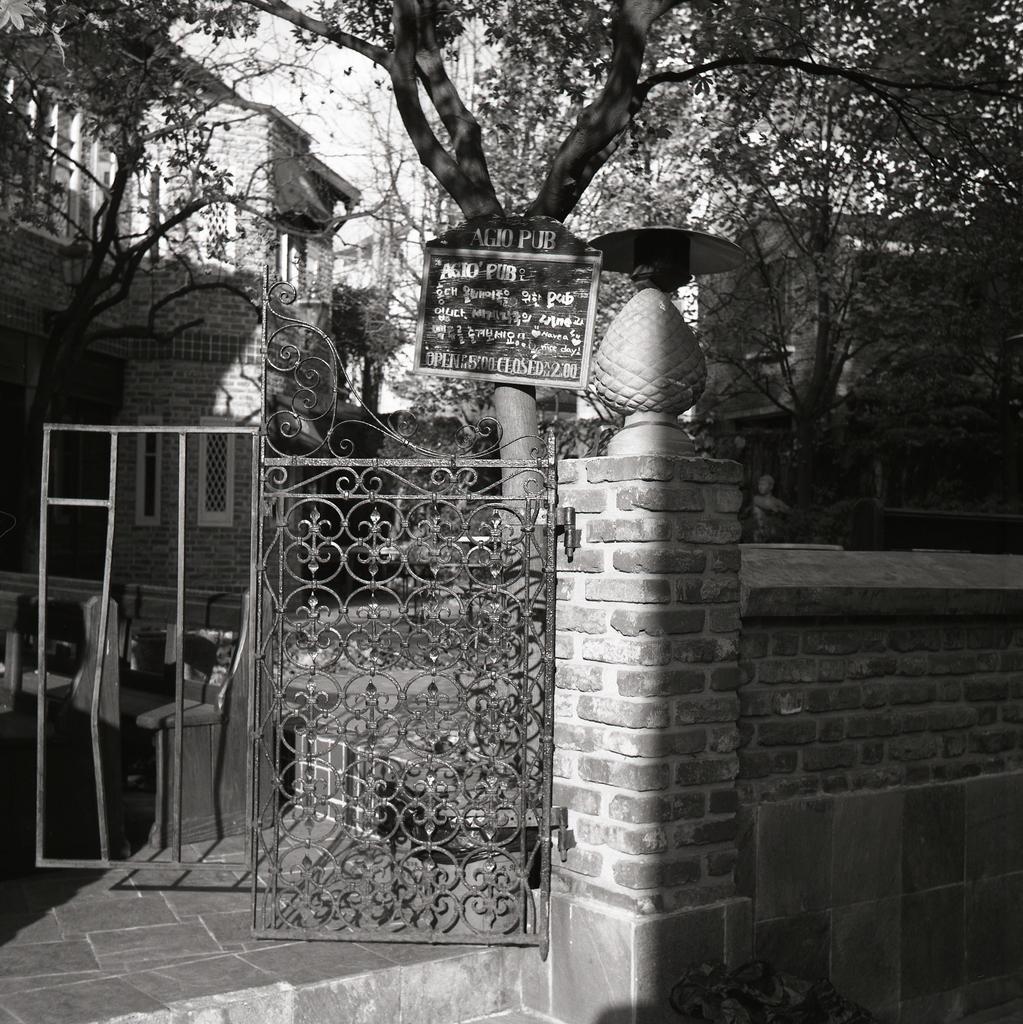Please provide a concise description of this image. This image is a black and white image. This image is taken outdoors. In the background there are a few buildings with walls, windows and roofs. There are a few trees. In the middle of the image there is a wall with a gate and there are a few benches on the floor. There is a board with a text on it. 